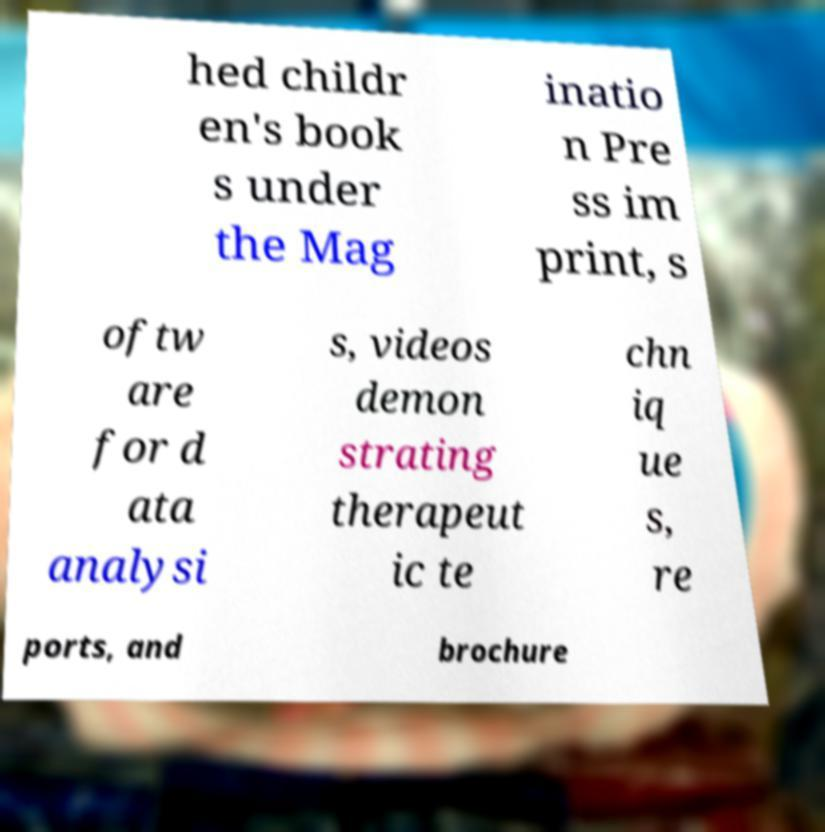Please identify and transcribe the text found in this image. hed childr en's book s under the Mag inatio n Pre ss im print, s oftw are for d ata analysi s, videos demon strating therapeut ic te chn iq ue s, re ports, and brochure 